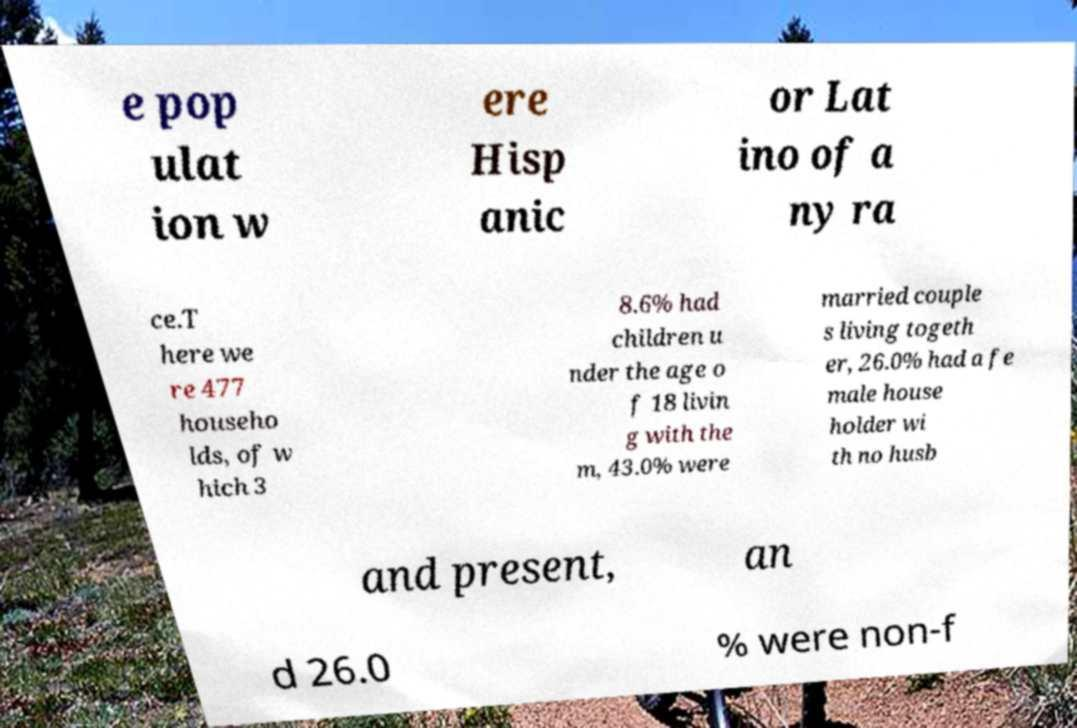For documentation purposes, I need the text within this image transcribed. Could you provide that? e pop ulat ion w ere Hisp anic or Lat ino of a ny ra ce.T here we re 477 househo lds, of w hich 3 8.6% had children u nder the age o f 18 livin g with the m, 43.0% were married couple s living togeth er, 26.0% had a fe male house holder wi th no husb and present, an d 26.0 % were non-f 